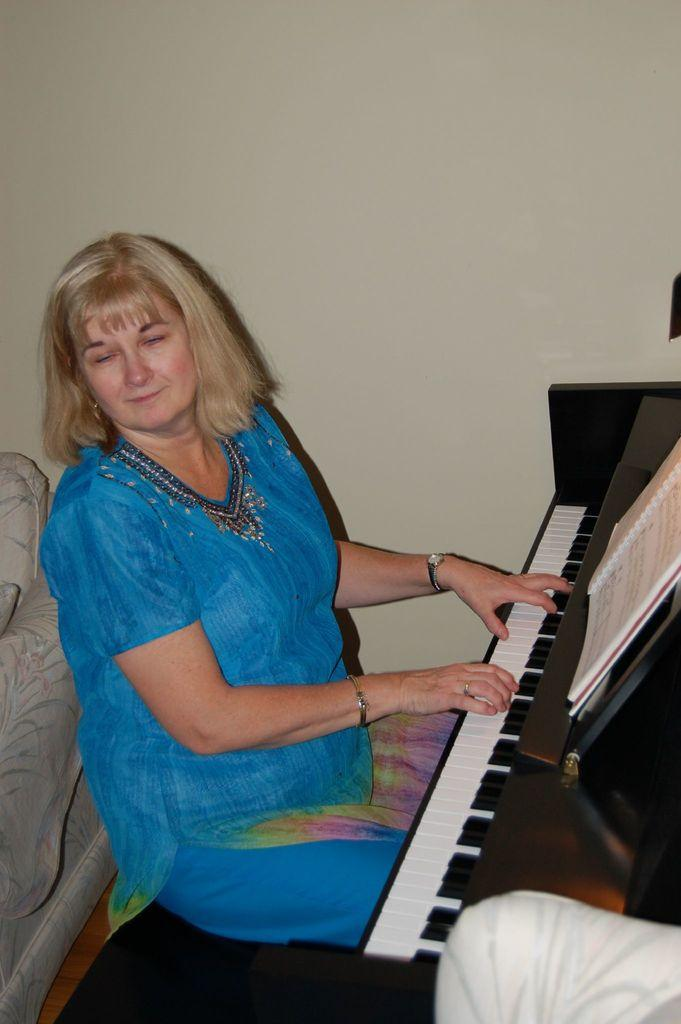Who is the main subject in the image? There is a lady in the image. What is the lady wearing? The lady is wearing a blue dress. What is the lady doing in the image? The lady is sitting and playing the piano. How many ducks are visible on the piano in the image? There are no ducks present on the piano or in the image. What letters can be seen on the top of the piano in the image? The image does not show any letters on the top of the piano. 